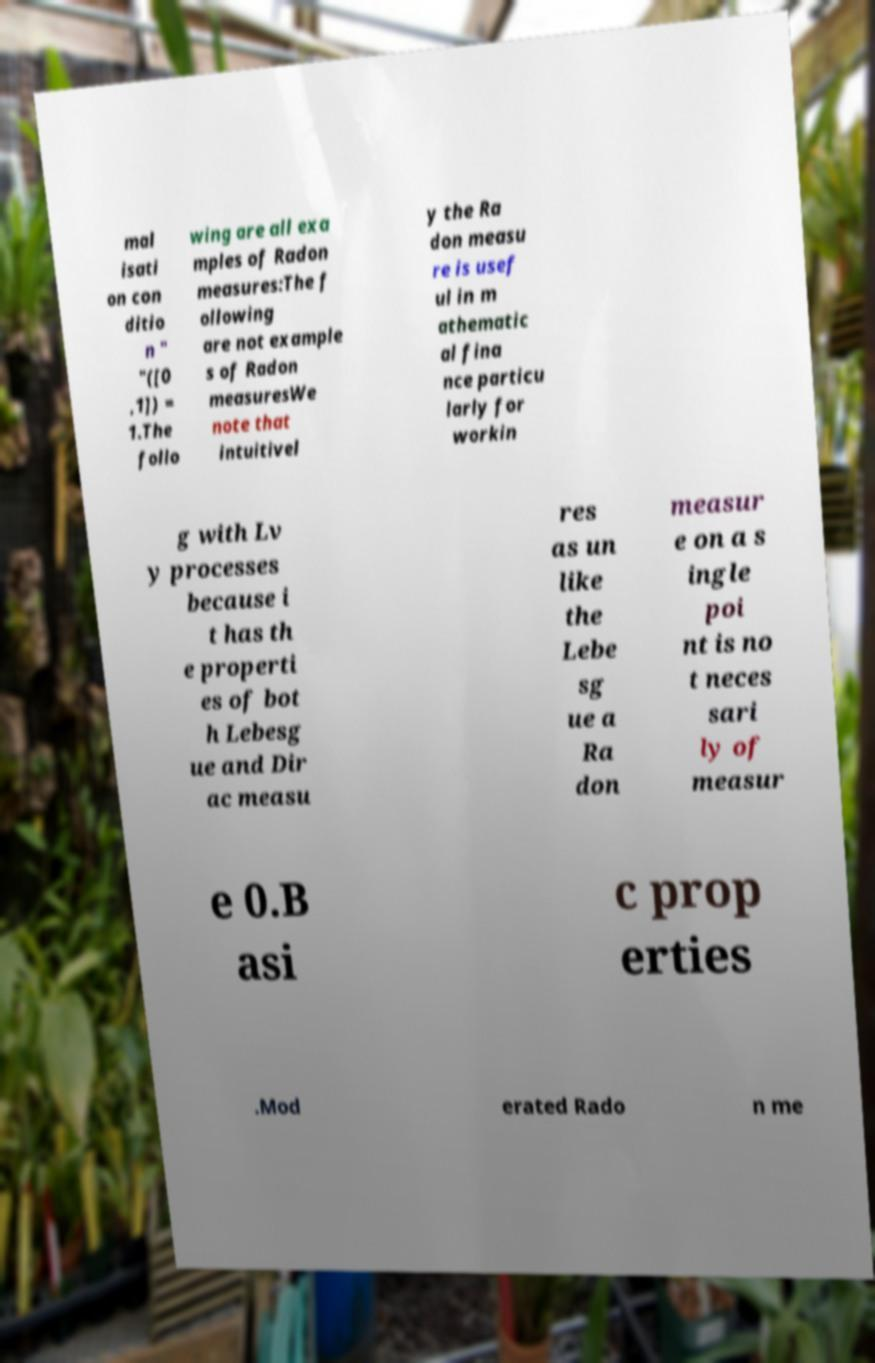Please identify and transcribe the text found in this image. mal isati on con ditio n " "([0 ,1]) = 1.The follo wing are all exa mples of Radon measures:The f ollowing are not example s of Radon measuresWe note that intuitivel y the Ra don measu re is usef ul in m athematic al fina nce particu larly for workin g with Lv y processes because i t has th e properti es of bot h Lebesg ue and Dir ac measu res as un like the Lebe sg ue a Ra don measur e on a s ingle poi nt is no t neces sari ly of measur e 0.B asi c prop erties .Mod erated Rado n me 